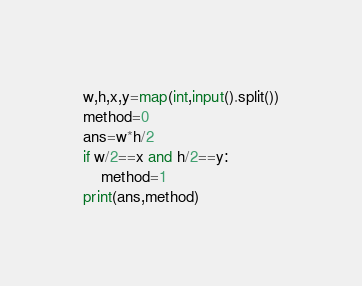Convert code to text. <code><loc_0><loc_0><loc_500><loc_500><_Python_>w,h,x,y=map(int,input().split())
method=0
ans=w*h/2
if w/2==x and h/2==y:
    method=1
print(ans,method)</code> 